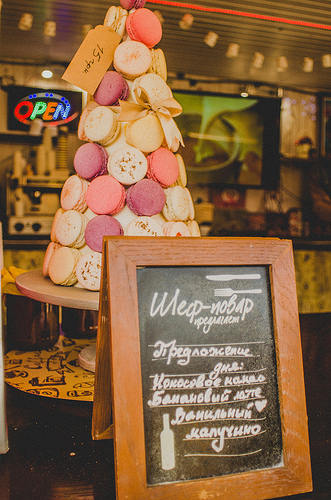<image>
Is there a chalkboard in front of the ribbon? Yes. The chalkboard is positioned in front of the ribbon, appearing closer to the camera viewpoint. 